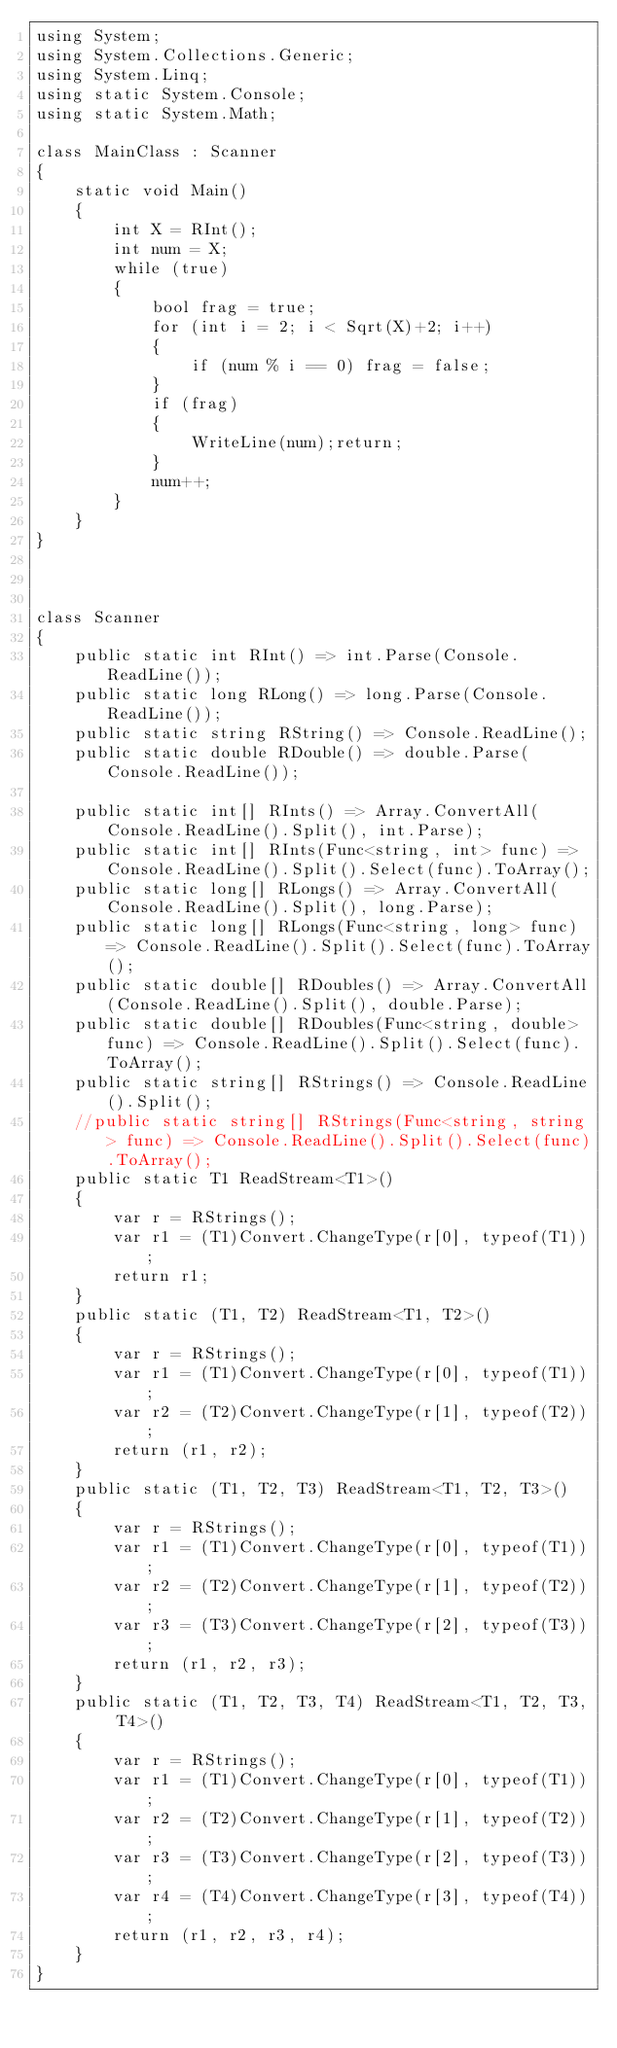Convert code to text. <code><loc_0><loc_0><loc_500><loc_500><_C#_>using System;
using System.Collections.Generic;
using System.Linq;
using static System.Console;
using static System.Math;

class MainClass : Scanner
{
    static void Main()
    {
        int X = RInt();
        int num = X;
        while (true)
        {
            bool frag = true;
            for (int i = 2; i < Sqrt(X)+2; i++)
            {
                if (num % i == 0) frag = false;
            }
            if (frag)
            {
                WriteLine(num);return;
            }
            num++;
        }
    }
}



class Scanner
{
    public static int RInt() => int.Parse(Console.ReadLine());
    public static long RLong() => long.Parse(Console.ReadLine());
    public static string RString() => Console.ReadLine();
    public static double RDouble() => double.Parse(Console.ReadLine());

    public static int[] RInts() => Array.ConvertAll(Console.ReadLine().Split(), int.Parse);
    public static int[] RInts(Func<string, int> func) => Console.ReadLine().Split().Select(func).ToArray();
    public static long[] RLongs() => Array.ConvertAll(Console.ReadLine().Split(), long.Parse);
    public static long[] RLongs(Func<string, long> func) => Console.ReadLine().Split().Select(func).ToArray();
    public static double[] RDoubles() => Array.ConvertAll(Console.ReadLine().Split(), double.Parse);
    public static double[] RDoubles(Func<string, double> func) => Console.ReadLine().Split().Select(func).ToArray();
    public static string[] RStrings() => Console.ReadLine().Split();
    //public static string[] RStrings(Func<string, string> func) => Console.ReadLine().Split().Select(func).ToArray();
    public static T1 ReadStream<T1>()
    {
        var r = RStrings();
        var r1 = (T1)Convert.ChangeType(r[0], typeof(T1));
        return r1;
    }
    public static (T1, T2) ReadStream<T1, T2>()
    {
        var r = RStrings();
        var r1 = (T1)Convert.ChangeType(r[0], typeof(T1));
        var r2 = (T2)Convert.ChangeType(r[1], typeof(T2));
        return (r1, r2);
    }
    public static (T1, T2, T3) ReadStream<T1, T2, T3>()
    {
        var r = RStrings();
        var r1 = (T1)Convert.ChangeType(r[0], typeof(T1));
        var r2 = (T2)Convert.ChangeType(r[1], typeof(T2));
        var r3 = (T3)Convert.ChangeType(r[2], typeof(T3));
        return (r1, r2, r3);
    }
    public static (T1, T2, T3, T4) ReadStream<T1, T2, T3, T4>()
    {
        var r = RStrings();
        var r1 = (T1)Convert.ChangeType(r[0], typeof(T1));
        var r2 = (T2)Convert.ChangeType(r[1], typeof(T2));
        var r3 = (T3)Convert.ChangeType(r[2], typeof(T3));
        var r4 = (T4)Convert.ChangeType(r[3], typeof(T4));
        return (r1, r2, r3, r4);
    }
}</code> 